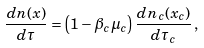<formula> <loc_0><loc_0><loc_500><loc_500>\frac { d n ( x ) } { d \tau } = \left ( 1 - \beta _ { c } \mu _ { c } \right ) \frac { d n _ { c } ( x _ { c } ) } { d \tau _ { c } } \, ,</formula> 